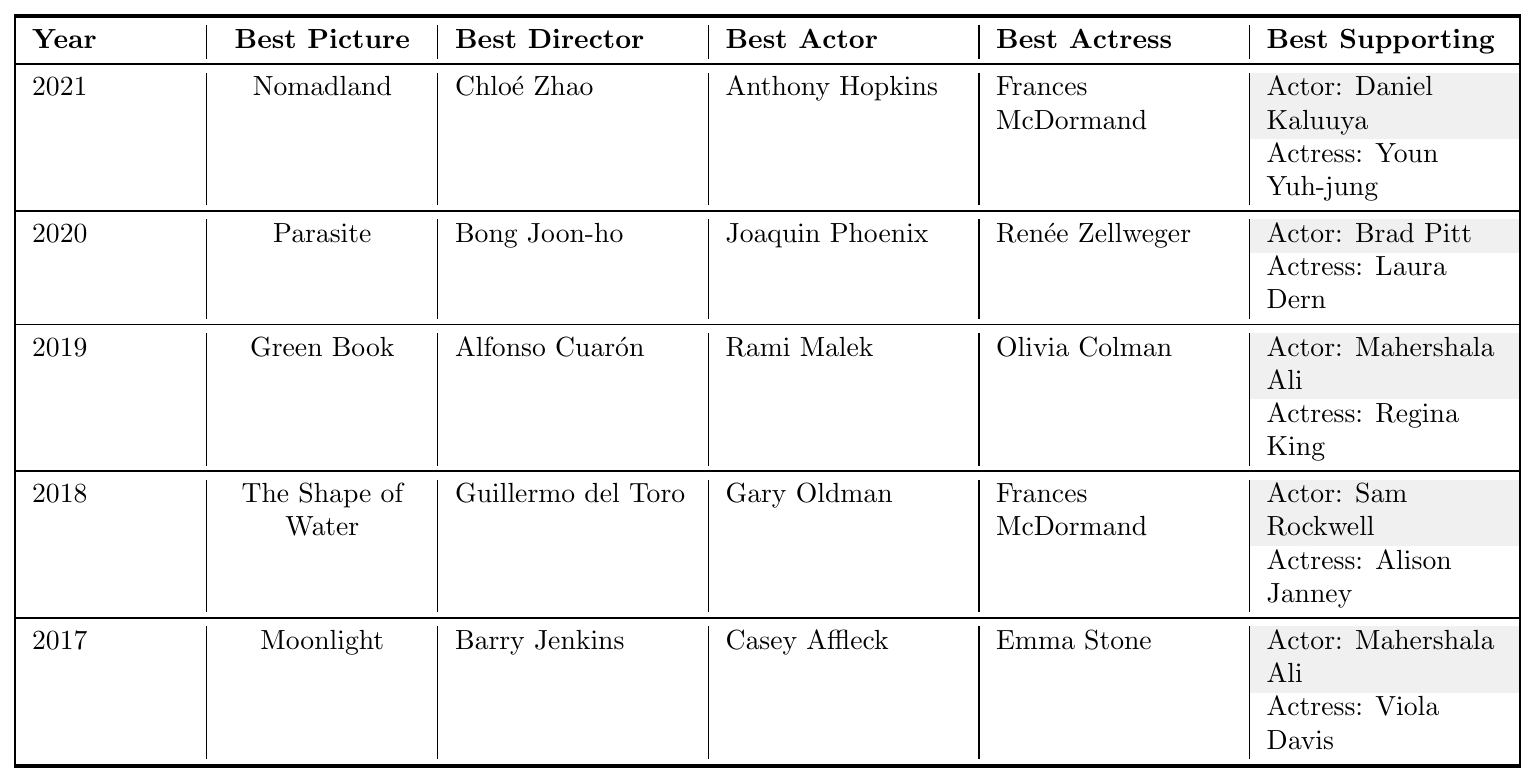What movie won the Best Picture award in 2021? According to the table, the Best Picture winner for 2021 is listed under the "Best Picture" column in the row for that year. The winner is "Nomadland."
Answer: Nomadland Who directed the movie that won Best Picture in 2020? The table displays the Best Director for 2020, which is in the same row as the Best Picture winner for that year "Parasite." The director is "Bong Joon-ho."
Answer: Bong Joon-ho Which actress won the Best Actress award in 2019? By looking at the table, the Best Actress for 2019 is found in the respective row for that year. The winner is "Olivia Colman."
Answer: Olivia Colman True or False: Anthony Hopkins won the Best Actor award in 2019. The table shows that Anthony Hopkins is the Best Actor winner for 2021, not 2019. Therefore, this statement is false.
Answer: False How many different actors won the Best Supporting Actor award from 2017 to 2021? We check the "Best Supporting Actor" winner from each row in the given years: Daniel Kaluuya (2021), Brad Pitt (2020), Mahershala Ali (2019 and 2017), and Sam Rockwell (2018). This gives us a total of four different actors.
Answer: 4 In which year did Frances McDormand win her second Best Actress award? The table indicates that Frances McDormand won Best Actress in both 2021 and 2018; thus, her second award was in 2021.
Answer: 2021 Which film won both Best Picture and Best Director in 2018? Looking at the table, we can see that "The Shape of Water" won Best Picture, and Guillermo del Toro won Best Director in the same year (2018). Hence, the same film achieved both awards.
Answer: The Shape of Water Did any actor win Best Supporting Actor more than once between 2017 and 2021? By checking the table, we find that Mahershala Ali won Best Supporting Actor in 2017 and again in 2019. Therefore, yes, he won it twice.
Answer: Yes What is the average number of Best Picture winners per year from 2017 to 2021? There are five different years shown (2017, 2018, 2019, 2020, and 2021) and five Best Picture winners. The average is calculated by dividing the total number of winners by the number of years (5/5 = 1).
Answer: 1 What is the trend of Best Director winners from 2017 to 2021? We can analyze the data by collecting the Best Director winners from each year: Barry Jenkins (2017), Guillermo del Toro (2018), Alfonso Cuarón (2019), Bong Joon-ho (2020), and Chloé Zhao (2021). There is no clear pattern or repeated winner in this time span.
Answer: No clear trend 